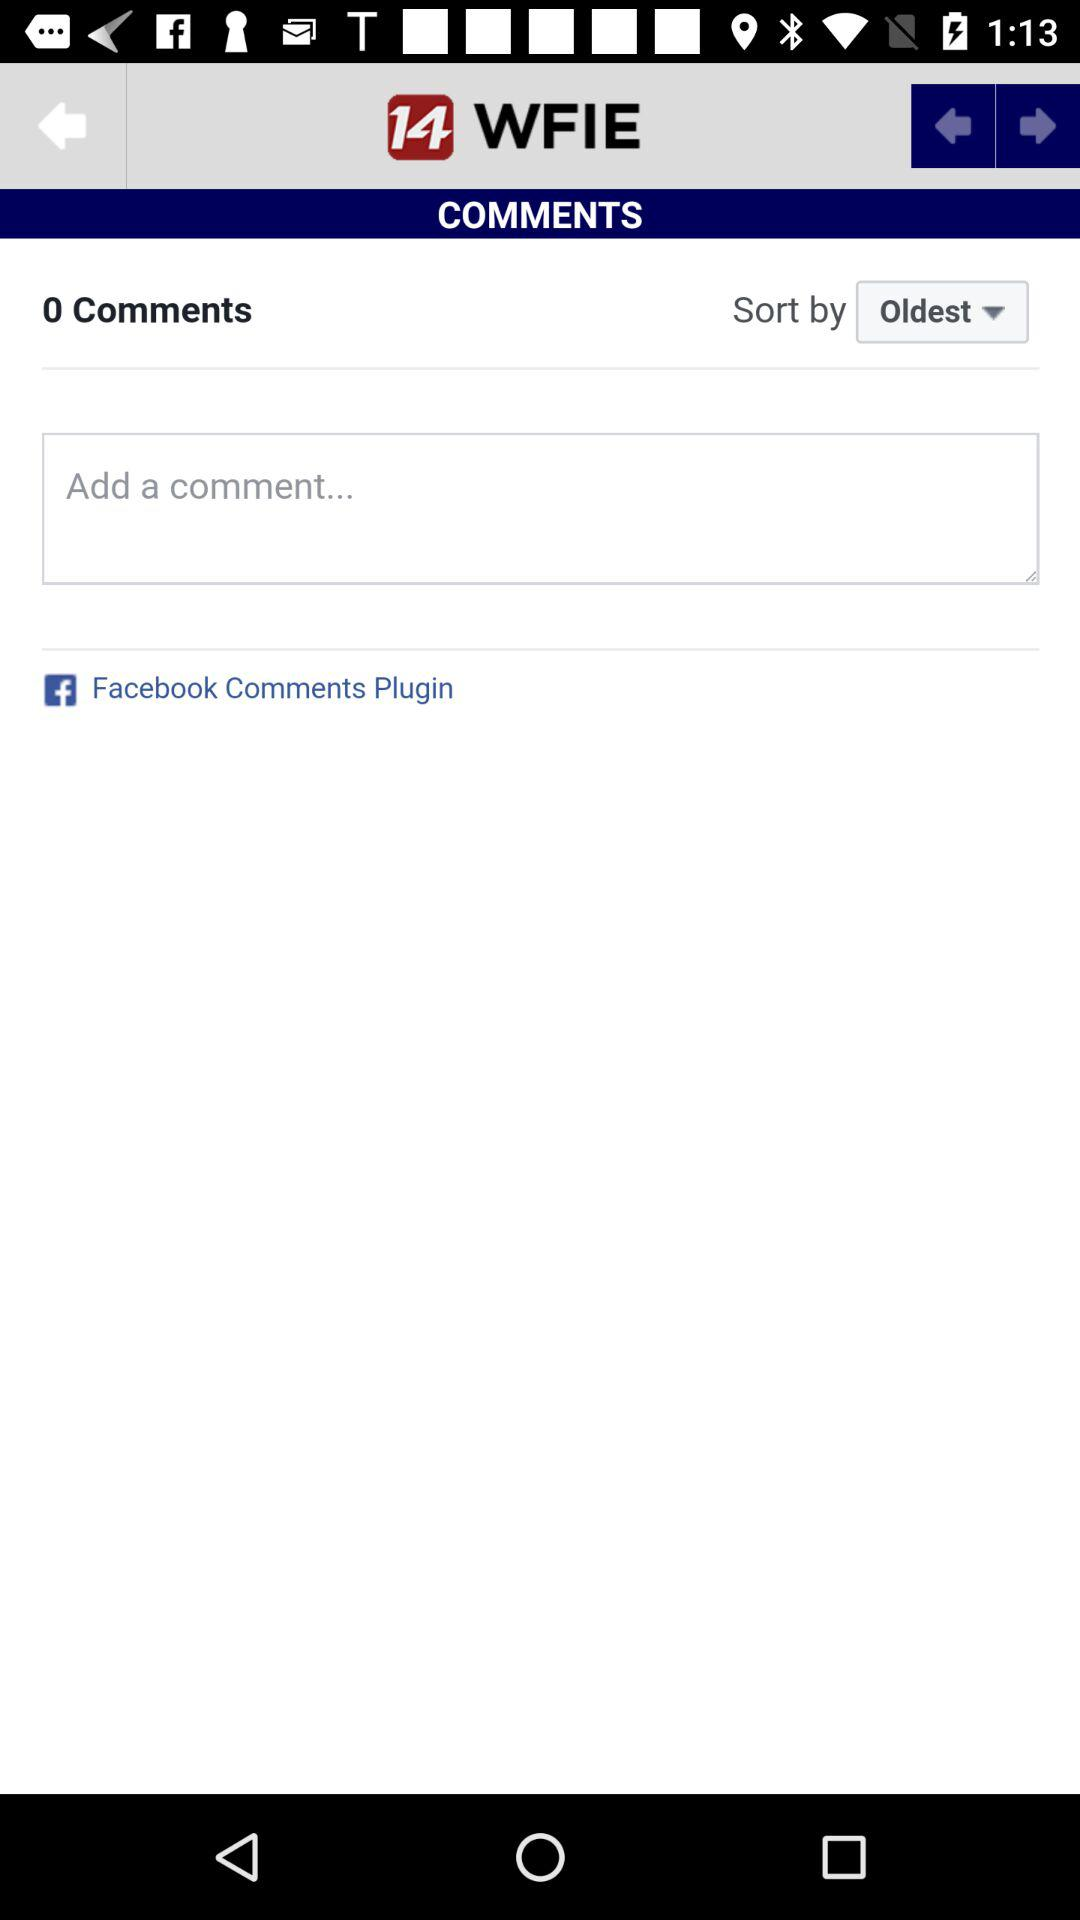How many comments are there? There are 0 comments. 